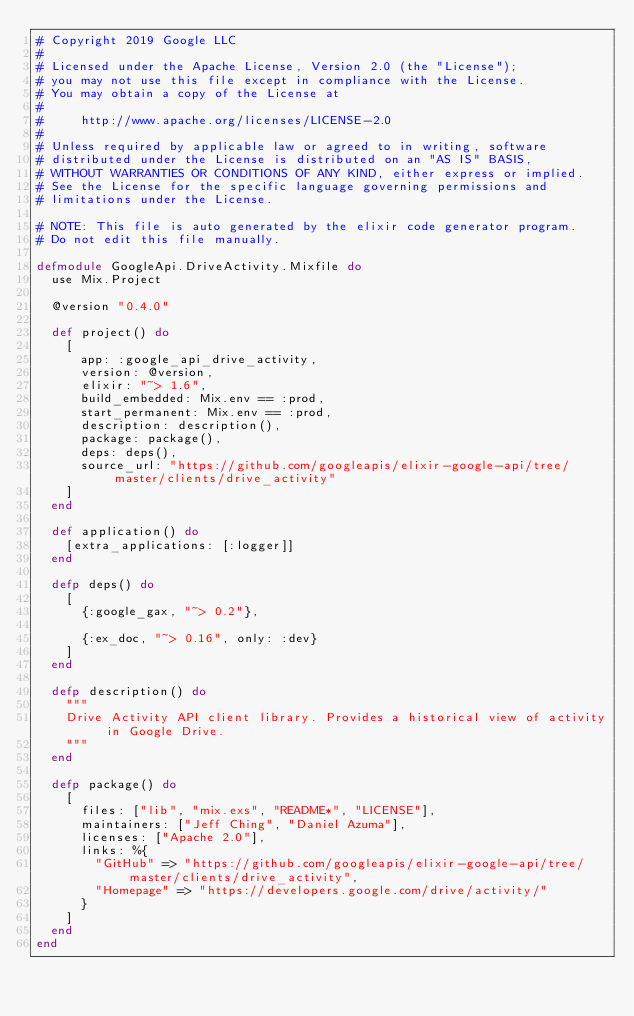Convert code to text. <code><loc_0><loc_0><loc_500><loc_500><_Elixir_># Copyright 2019 Google LLC
#
# Licensed under the Apache License, Version 2.0 (the "License");
# you may not use this file except in compliance with the License.
# You may obtain a copy of the License at
#
#     http://www.apache.org/licenses/LICENSE-2.0
#
# Unless required by applicable law or agreed to in writing, software
# distributed under the License is distributed on an "AS IS" BASIS,
# WITHOUT WARRANTIES OR CONDITIONS OF ANY KIND, either express or implied.
# See the License for the specific language governing permissions and
# limitations under the License.

# NOTE: This file is auto generated by the elixir code generator program.
# Do not edit this file manually.

defmodule GoogleApi.DriveActivity.Mixfile do
  use Mix.Project

  @version "0.4.0"

  def project() do
    [
      app: :google_api_drive_activity,
      version: @version,
      elixir: "~> 1.6",
      build_embedded: Mix.env == :prod,
      start_permanent: Mix.env == :prod,
      description: description(),
      package: package(),
      deps: deps(),
      source_url: "https://github.com/googleapis/elixir-google-api/tree/master/clients/drive_activity"
    ]
  end

  def application() do
    [extra_applications: [:logger]]
  end

  defp deps() do
    [
      {:google_gax, "~> 0.2"},

      {:ex_doc, "~> 0.16", only: :dev}
    ]
  end

  defp description() do
    """
    Drive Activity API client library. Provides a historical view of activity in Google Drive.
    """
  end

  defp package() do
    [
      files: ["lib", "mix.exs", "README*", "LICENSE"],
      maintainers: ["Jeff Ching", "Daniel Azuma"],
      licenses: ["Apache 2.0"],
      links: %{
        "GitHub" => "https://github.com/googleapis/elixir-google-api/tree/master/clients/drive_activity",
        "Homepage" => "https://developers.google.com/drive/activity/"
      }
    ]
  end
end
</code> 